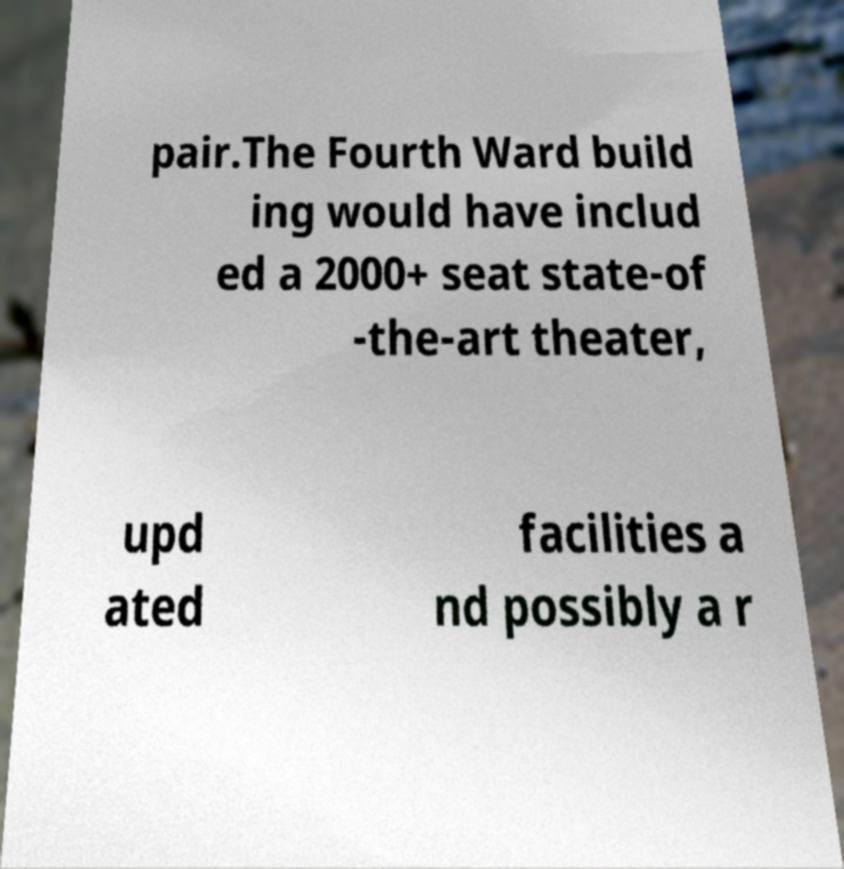I need the written content from this picture converted into text. Can you do that? pair.The Fourth Ward build ing would have includ ed a 2000+ seat state-of -the-art theater, upd ated facilities a nd possibly a r 